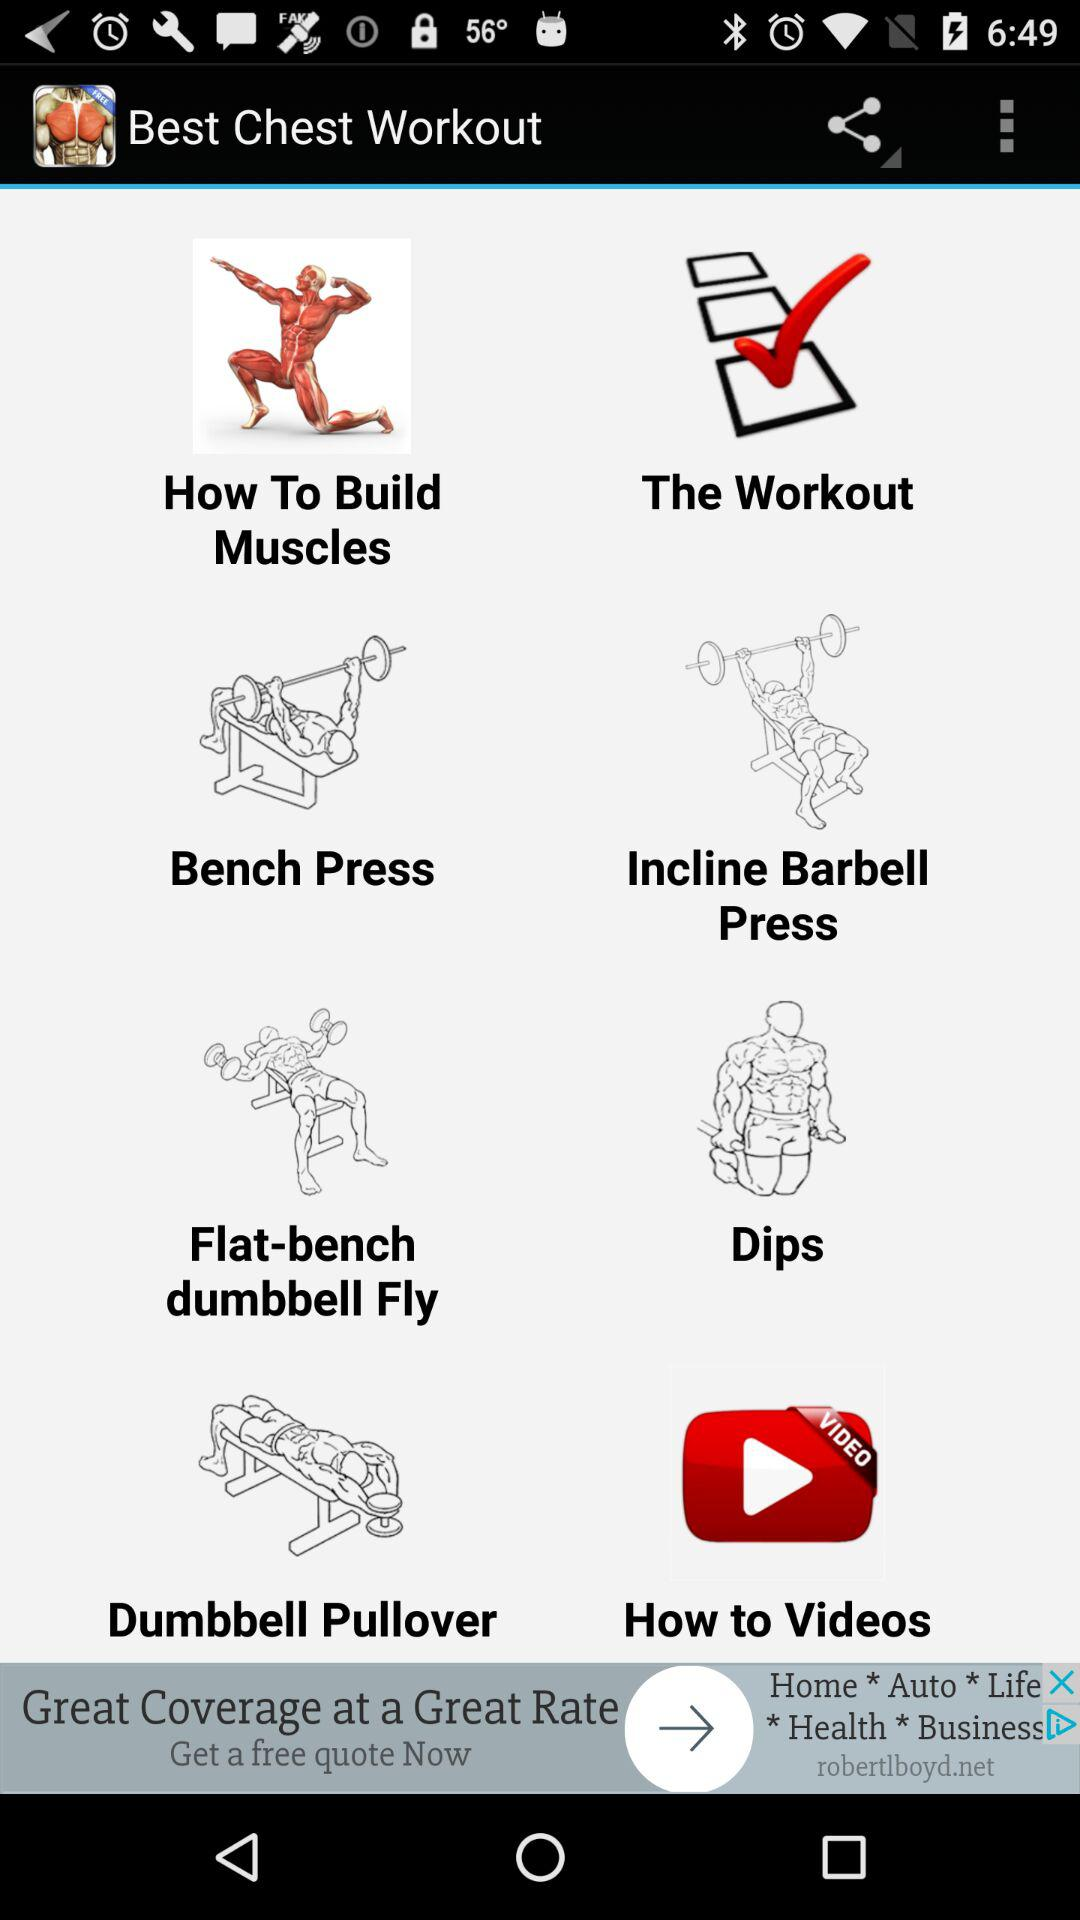What is the application name? The application name is "Best Chest Workout". 